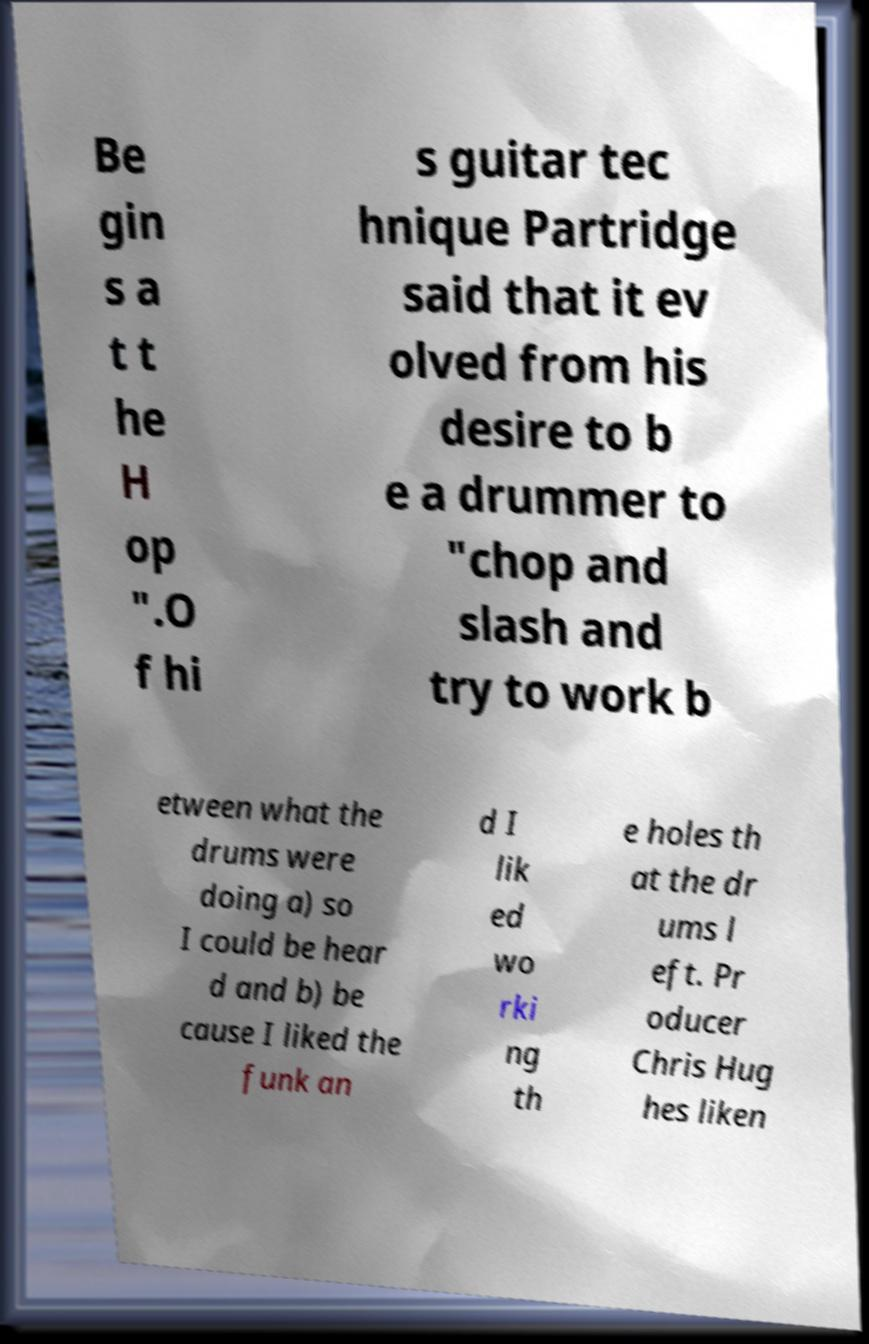Please identify and transcribe the text found in this image. Be gin s a t t he H op ".O f hi s guitar tec hnique Partridge said that it ev olved from his desire to b e a drummer to "chop and slash and try to work b etween what the drums were doing a) so I could be hear d and b) be cause I liked the funk an d I lik ed wo rki ng th e holes th at the dr ums l eft. Pr oducer Chris Hug hes liken 